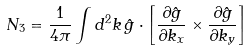Convert formula to latex. <formula><loc_0><loc_0><loc_500><loc_500>N _ { 3 } = \frac { 1 } { 4 \pi } \int d ^ { 2 } k \, \hat { g } \cdot \left [ \frac { \partial \hat { g } } { \partial { k _ { x } } } \times \frac { \partial \hat { g } } { \partial { k _ { y } } } \right ]</formula> 